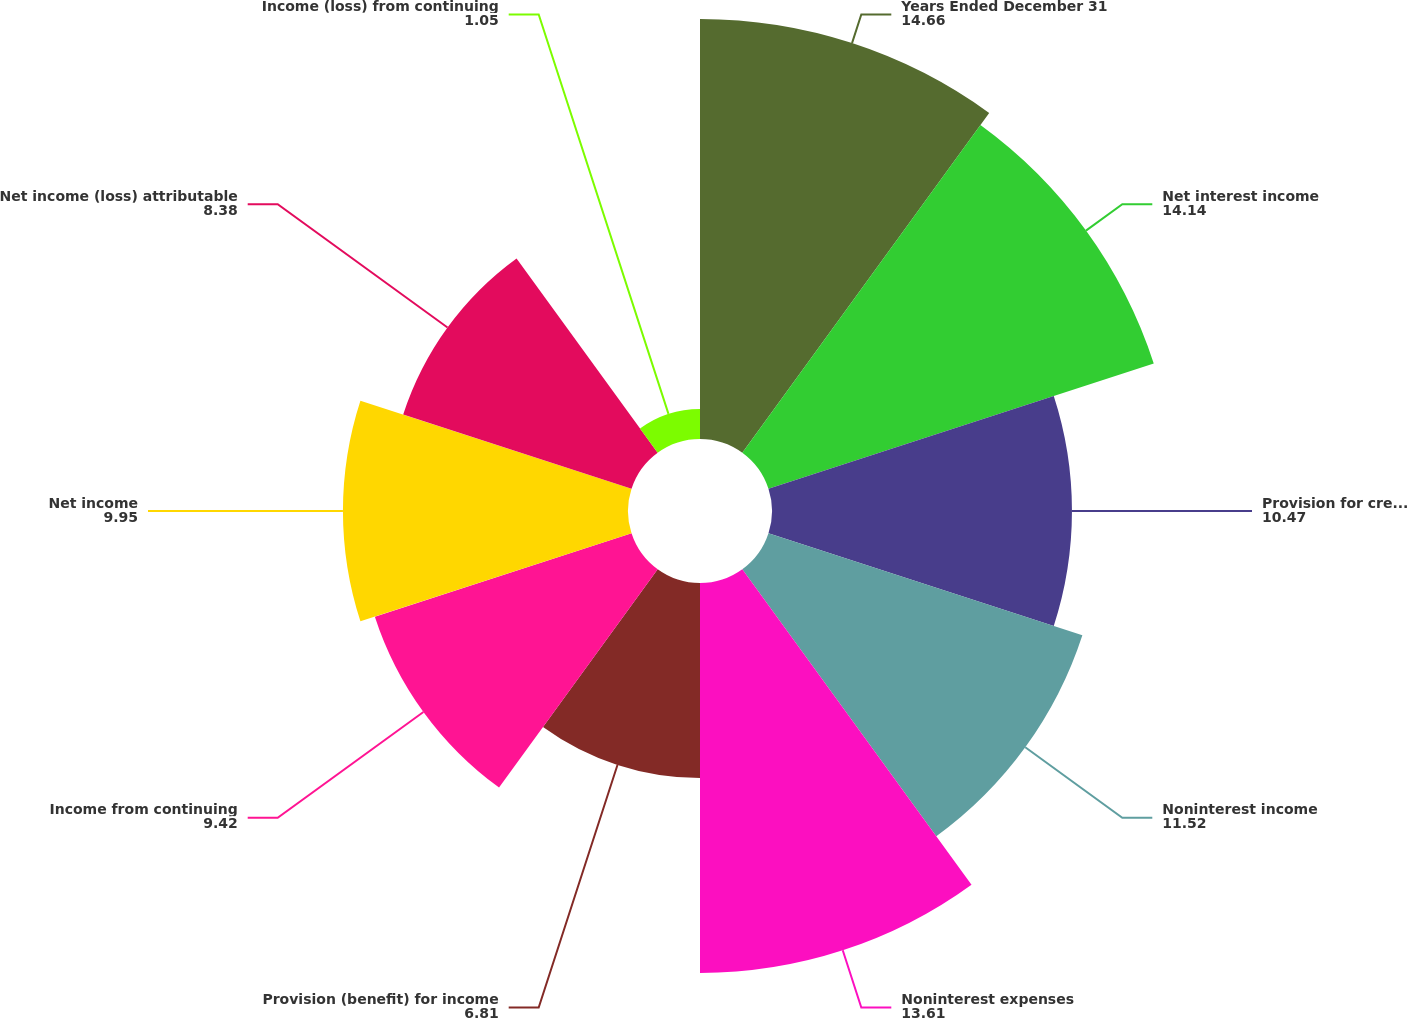Convert chart. <chart><loc_0><loc_0><loc_500><loc_500><pie_chart><fcel>Years Ended December 31<fcel>Net interest income<fcel>Provision for credit losses<fcel>Noninterest income<fcel>Noninterest expenses<fcel>Provision (benefit) for income<fcel>Income from continuing<fcel>Net income<fcel>Net income (loss) attributable<fcel>Income (loss) from continuing<nl><fcel>14.66%<fcel>14.14%<fcel>10.47%<fcel>11.52%<fcel>13.61%<fcel>6.81%<fcel>9.42%<fcel>9.95%<fcel>8.38%<fcel>1.05%<nl></chart> 